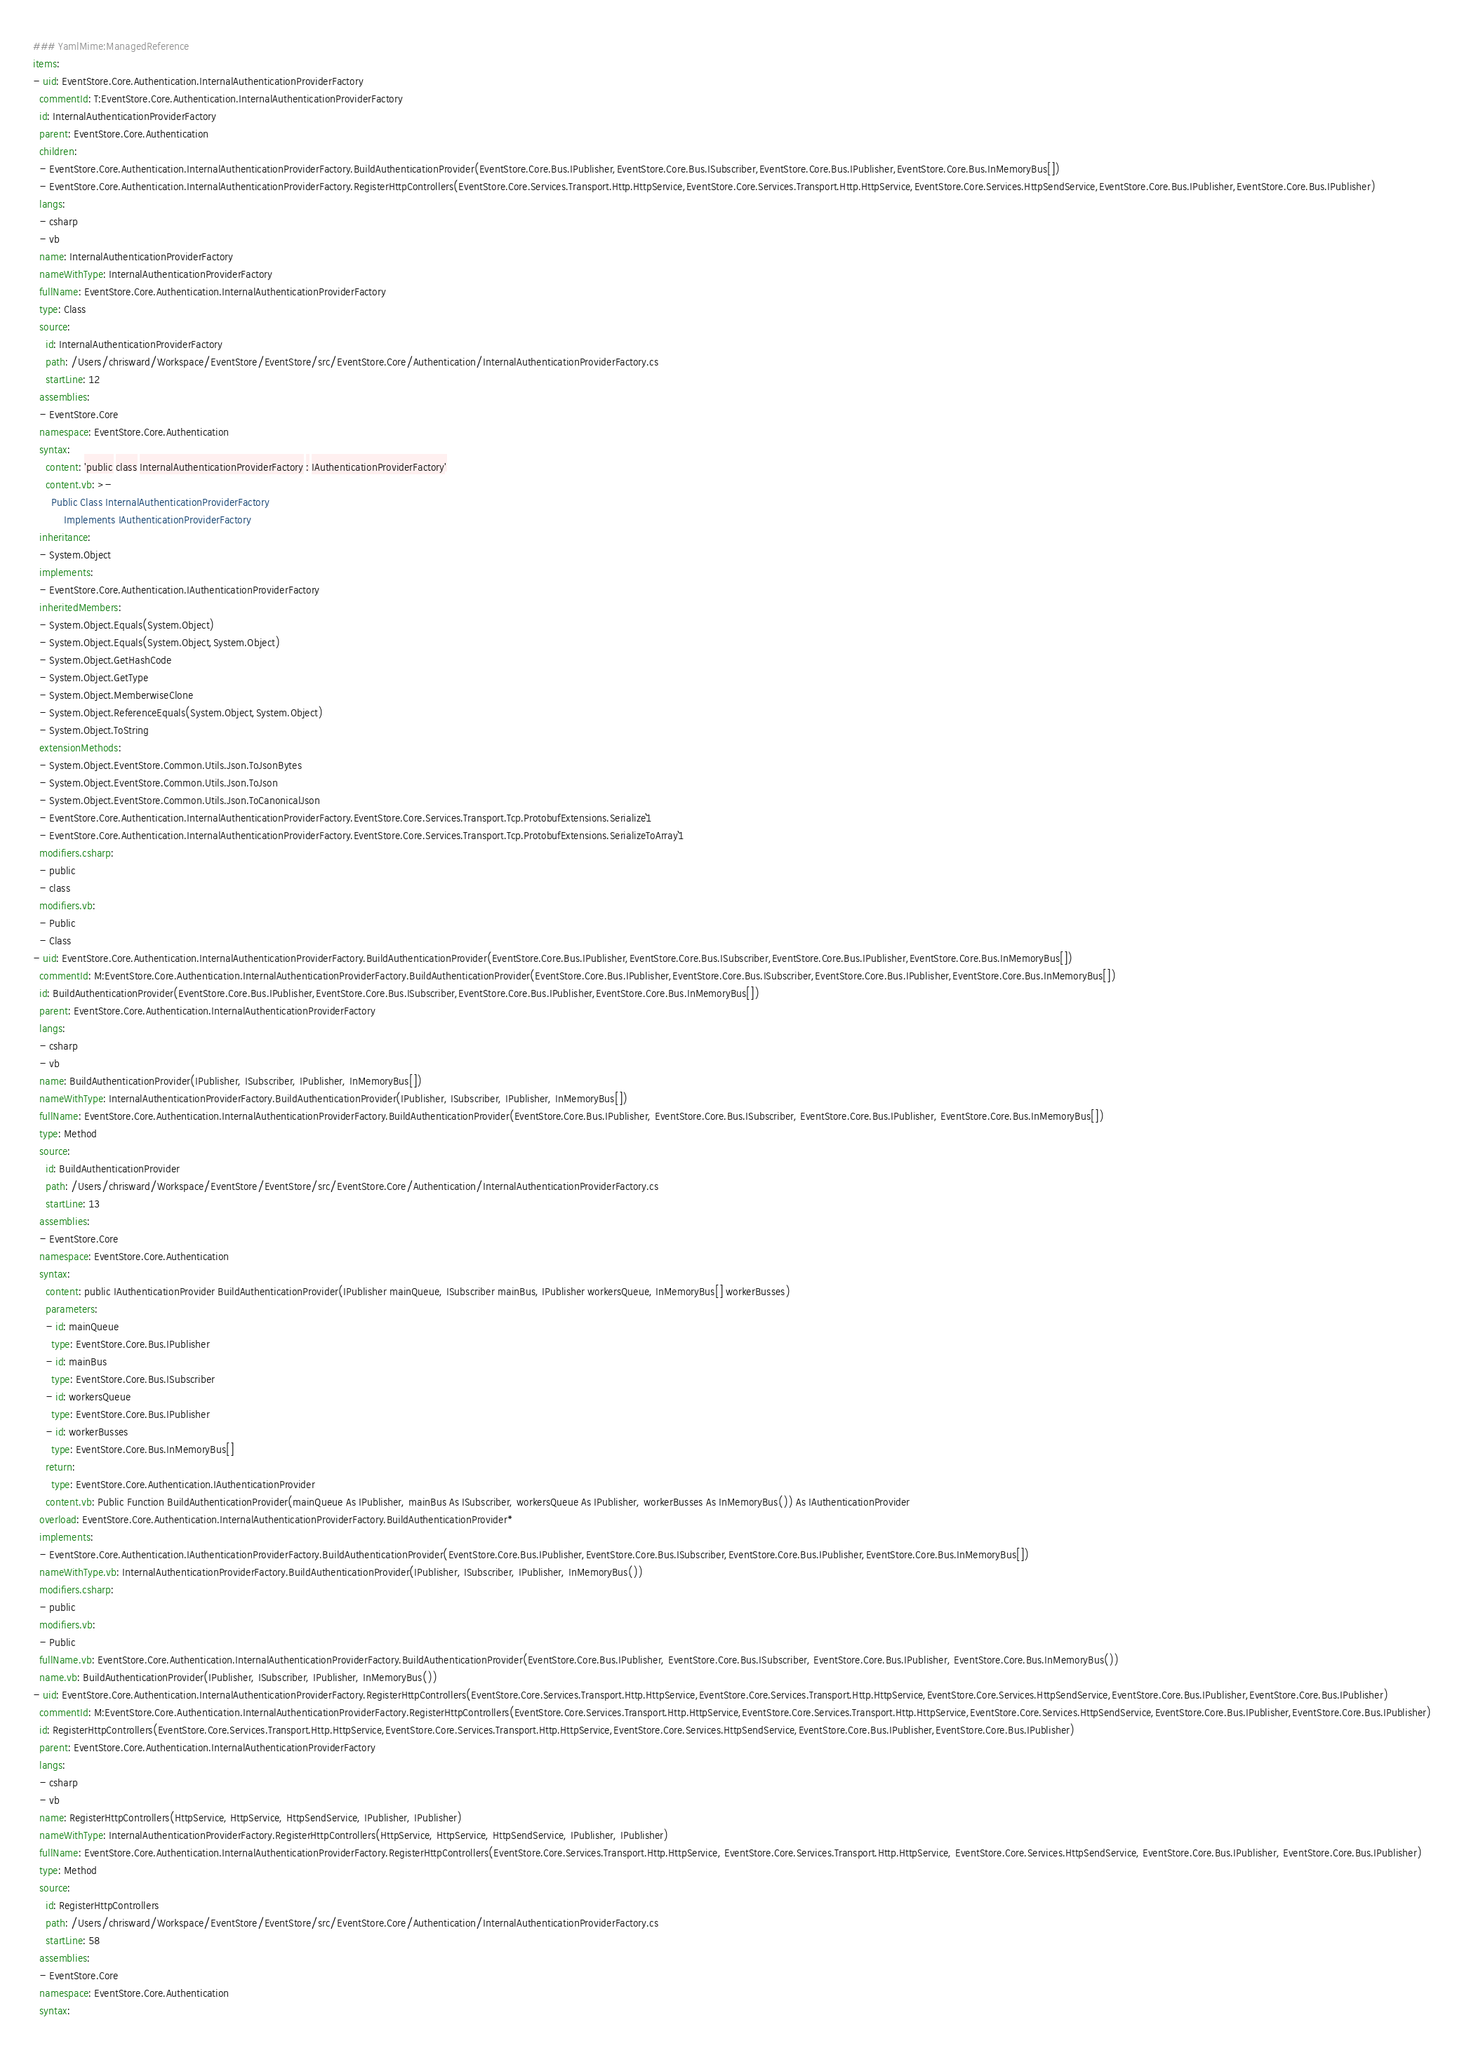Convert code to text. <code><loc_0><loc_0><loc_500><loc_500><_YAML_>### YamlMime:ManagedReference
items:
- uid: EventStore.Core.Authentication.InternalAuthenticationProviderFactory
  commentId: T:EventStore.Core.Authentication.InternalAuthenticationProviderFactory
  id: InternalAuthenticationProviderFactory
  parent: EventStore.Core.Authentication
  children:
  - EventStore.Core.Authentication.InternalAuthenticationProviderFactory.BuildAuthenticationProvider(EventStore.Core.Bus.IPublisher,EventStore.Core.Bus.ISubscriber,EventStore.Core.Bus.IPublisher,EventStore.Core.Bus.InMemoryBus[])
  - EventStore.Core.Authentication.InternalAuthenticationProviderFactory.RegisterHttpControllers(EventStore.Core.Services.Transport.Http.HttpService,EventStore.Core.Services.Transport.Http.HttpService,EventStore.Core.Services.HttpSendService,EventStore.Core.Bus.IPublisher,EventStore.Core.Bus.IPublisher)
  langs:
  - csharp
  - vb
  name: InternalAuthenticationProviderFactory
  nameWithType: InternalAuthenticationProviderFactory
  fullName: EventStore.Core.Authentication.InternalAuthenticationProviderFactory
  type: Class
  source:
    id: InternalAuthenticationProviderFactory
    path: /Users/chrisward/Workspace/EventStore/EventStore/src/EventStore.Core/Authentication/InternalAuthenticationProviderFactory.cs
    startLine: 12
  assemblies:
  - EventStore.Core
  namespace: EventStore.Core.Authentication
  syntax:
    content: 'public class InternalAuthenticationProviderFactory : IAuthenticationProviderFactory'
    content.vb: >-
      Public Class InternalAuthenticationProviderFactory
          Implements IAuthenticationProviderFactory
  inheritance:
  - System.Object
  implements:
  - EventStore.Core.Authentication.IAuthenticationProviderFactory
  inheritedMembers:
  - System.Object.Equals(System.Object)
  - System.Object.Equals(System.Object,System.Object)
  - System.Object.GetHashCode
  - System.Object.GetType
  - System.Object.MemberwiseClone
  - System.Object.ReferenceEquals(System.Object,System.Object)
  - System.Object.ToString
  extensionMethods:
  - System.Object.EventStore.Common.Utils.Json.ToJsonBytes
  - System.Object.EventStore.Common.Utils.Json.ToJson
  - System.Object.EventStore.Common.Utils.Json.ToCanonicalJson
  - EventStore.Core.Authentication.InternalAuthenticationProviderFactory.EventStore.Core.Services.Transport.Tcp.ProtobufExtensions.Serialize``1
  - EventStore.Core.Authentication.InternalAuthenticationProviderFactory.EventStore.Core.Services.Transport.Tcp.ProtobufExtensions.SerializeToArray``1
  modifiers.csharp:
  - public
  - class
  modifiers.vb:
  - Public
  - Class
- uid: EventStore.Core.Authentication.InternalAuthenticationProviderFactory.BuildAuthenticationProvider(EventStore.Core.Bus.IPublisher,EventStore.Core.Bus.ISubscriber,EventStore.Core.Bus.IPublisher,EventStore.Core.Bus.InMemoryBus[])
  commentId: M:EventStore.Core.Authentication.InternalAuthenticationProviderFactory.BuildAuthenticationProvider(EventStore.Core.Bus.IPublisher,EventStore.Core.Bus.ISubscriber,EventStore.Core.Bus.IPublisher,EventStore.Core.Bus.InMemoryBus[])
  id: BuildAuthenticationProvider(EventStore.Core.Bus.IPublisher,EventStore.Core.Bus.ISubscriber,EventStore.Core.Bus.IPublisher,EventStore.Core.Bus.InMemoryBus[])
  parent: EventStore.Core.Authentication.InternalAuthenticationProviderFactory
  langs:
  - csharp
  - vb
  name: BuildAuthenticationProvider(IPublisher, ISubscriber, IPublisher, InMemoryBus[])
  nameWithType: InternalAuthenticationProviderFactory.BuildAuthenticationProvider(IPublisher, ISubscriber, IPublisher, InMemoryBus[])
  fullName: EventStore.Core.Authentication.InternalAuthenticationProviderFactory.BuildAuthenticationProvider(EventStore.Core.Bus.IPublisher, EventStore.Core.Bus.ISubscriber, EventStore.Core.Bus.IPublisher, EventStore.Core.Bus.InMemoryBus[])
  type: Method
  source:
    id: BuildAuthenticationProvider
    path: /Users/chrisward/Workspace/EventStore/EventStore/src/EventStore.Core/Authentication/InternalAuthenticationProviderFactory.cs
    startLine: 13
  assemblies:
  - EventStore.Core
  namespace: EventStore.Core.Authentication
  syntax:
    content: public IAuthenticationProvider BuildAuthenticationProvider(IPublisher mainQueue, ISubscriber mainBus, IPublisher workersQueue, InMemoryBus[] workerBusses)
    parameters:
    - id: mainQueue
      type: EventStore.Core.Bus.IPublisher
    - id: mainBus
      type: EventStore.Core.Bus.ISubscriber
    - id: workersQueue
      type: EventStore.Core.Bus.IPublisher
    - id: workerBusses
      type: EventStore.Core.Bus.InMemoryBus[]
    return:
      type: EventStore.Core.Authentication.IAuthenticationProvider
    content.vb: Public Function BuildAuthenticationProvider(mainQueue As IPublisher, mainBus As ISubscriber, workersQueue As IPublisher, workerBusses As InMemoryBus()) As IAuthenticationProvider
  overload: EventStore.Core.Authentication.InternalAuthenticationProviderFactory.BuildAuthenticationProvider*
  implements:
  - EventStore.Core.Authentication.IAuthenticationProviderFactory.BuildAuthenticationProvider(EventStore.Core.Bus.IPublisher,EventStore.Core.Bus.ISubscriber,EventStore.Core.Bus.IPublisher,EventStore.Core.Bus.InMemoryBus[])
  nameWithType.vb: InternalAuthenticationProviderFactory.BuildAuthenticationProvider(IPublisher, ISubscriber, IPublisher, InMemoryBus())
  modifiers.csharp:
  - public
  modifiers.vb:
  - Public
  fullName.vb: EventStore.Core.Authentication.InternalAuthenticationProviderFactory.BuildAuthenticationProvider(EventStore.Core.Bus.IPublisher, EventStore.Core.Bus.ISubscriber, EventStore.Core.Bus.IPublisher, EventStore.Core.Bus.InMemoryBus())
  name.vb: BuildAuthenticationProvider(IPublisher, ISubscriber, IPublisher, InMemoryBus())
- uid: EventStore.Core.Authentication.InternalAuthenticationProviderFactory.RegisterHttpControllers(EventStore.Core.Services.Transport.Http.HttpService,EventStore.Core.Services.Transport.Http.HttpService,EventStore.Core.Services.HttpSendService,EventStore.Core.Bus.IPublisher,EventStore.Core.Bus.IPublisher)
  commentId: M:EventStore.Core.Authentication.InternalAuthenticationProviderFactory.RegisterHttpControllers(EventStore.Core.Services.Transport.Http.HttpService,EventStore.Core.Services.Transport.Http.HttpService,EventStore.Core.Services.HttpSendService,EventStore.Core.Bus.IPublisher,EventStore.Core.Bus.IPublisher)
  id: RegisterHttpControllers(EventStore.Core.Services.Transport.Http.HttpService,EventStore.Core.Services.Transport.Http.HttpService,EventStore.Core.Services.HttpSendService,EventStore.Core.Bus.IPublisher,EventStore.Core.Bus.IPublisher)
  parent: EventStore.Core.Authentication.InternalAuthenticationProviderFactory
  langs:
  - csharp
  - vb
  name: RegisterHttpControllers(HttpService, HttpService, HttpSendService, IPublisher, IPublisher)
  nameWithType: InternalAuthenticationProviderFactory.RegisterHttpControllers(HttpService, HttpService, HttpSendService, IPublisher, IPublisher)
  fullName: EventStore.Core.Authentication.InternalAuthenticationProviderFactory.RegisterHttpControllers(EventStore.Core.Services.Transport.Http.HttpService, EventStore.Core.Services.Transport.Http.HttpService, EventStore.Core.Services.HttpSendService, EventStore.Core.Bus.IPublisher, EventStore.Core.Bus.IPublisher)
  type: Method
  source:
    id: RegisterHttpControllers
    path: /Users/chrisward/Workspace/EventStore/EventStore/src/EventStore.Core/Authentication/InternalAuthenticationProviderFactory.cs
    startLine: 58
  assemblies:
  - EventStore.Core
  namespace: EventStore.Core.Authentication
  syntax:</code> 